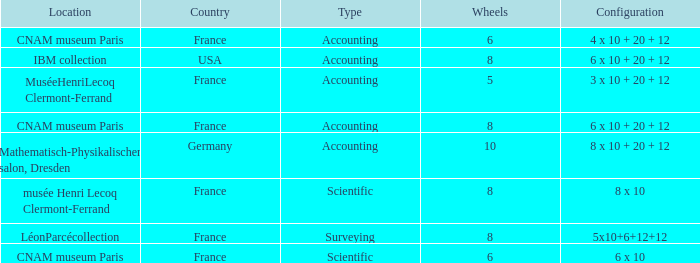What average wheels has accounting as the type, with IBM Collection as the location? 8.0. 